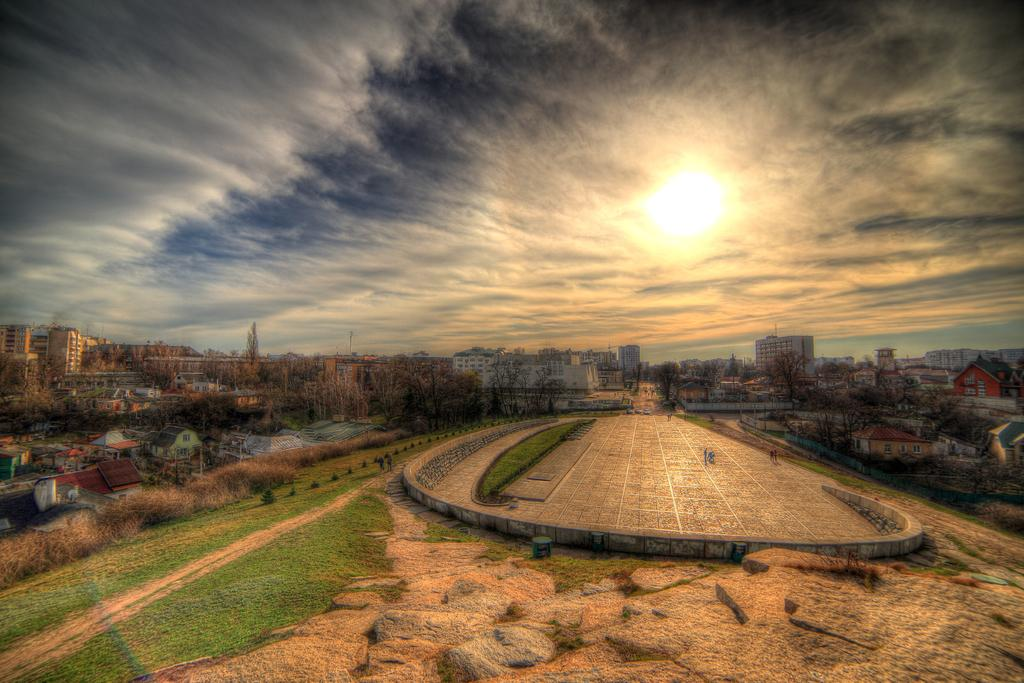Who or what can be seen in the image? There are people in the image. What type of structures are present in the image? There are houses and buildings in the image. What type of vegetation is visible in the image? There are trees in the image. What is visible in the sky in the image? Clouds are visible in the image. What color are the eggs in the image? There are no eggs present in the image. How many members of the family can be seen in the image? There is no family depicted in the image; only people, houses, buildings, trees, and clouds are visible. 